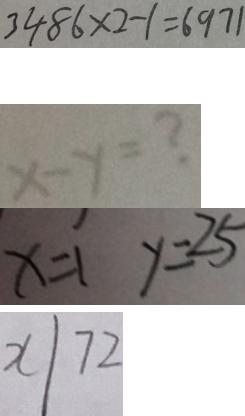Convert formula to latex. <formula><loc_0><loc_0><loc_500><loc_500>3 4 8 6 \times 2 - 1 = 6 9 7 1 
 x - y = ? 
 x = 1 y = 2 5 
 x / 7 2</formula> 